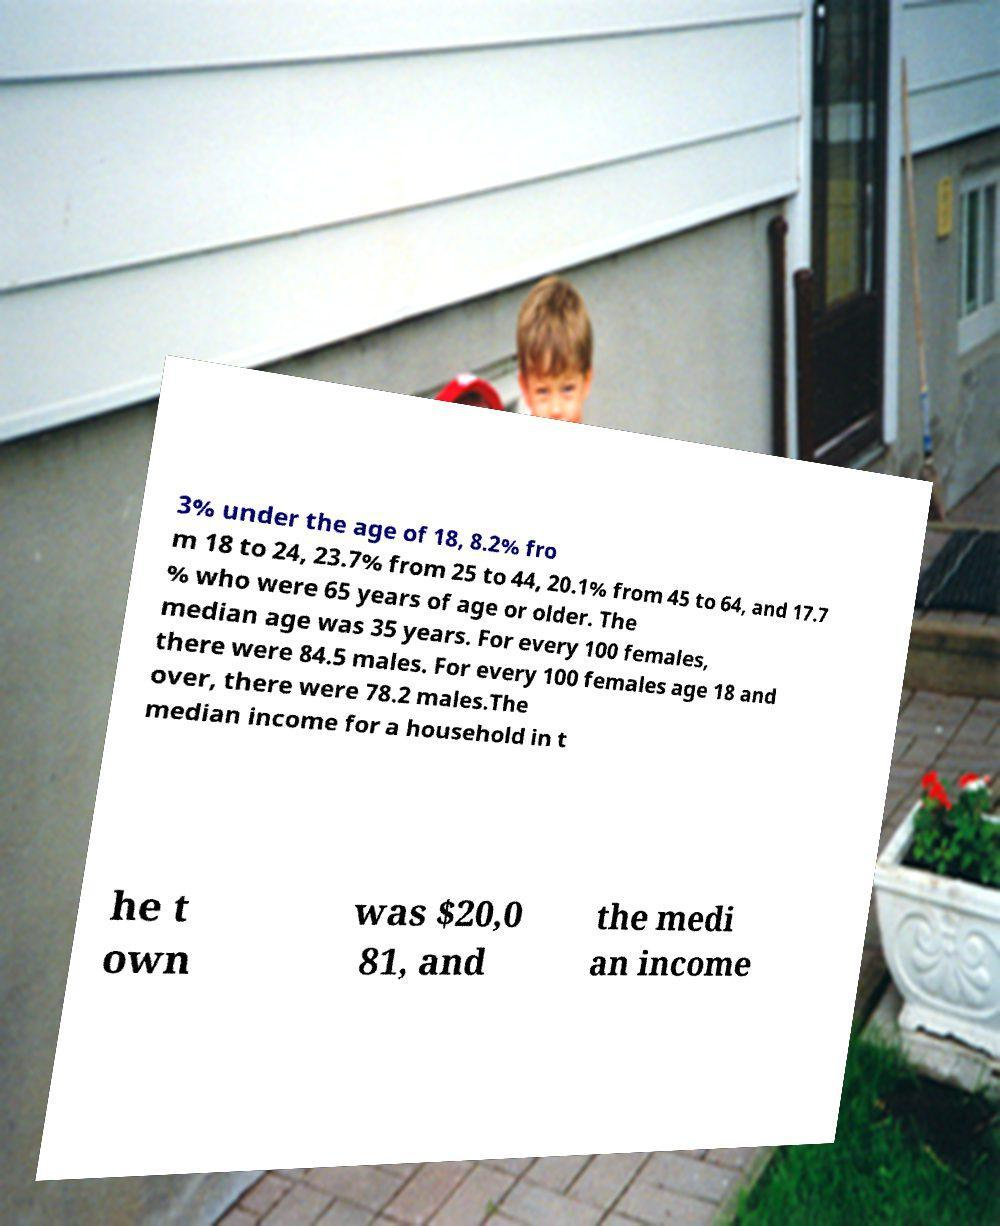Can you accurately transcribe the text from the provided image for me? 3% under the age of 18, 8.2% fro m 18 to 24, 23.7% from 25 to 44, 20.1% from 45 to 64, and 17.7 % who were 65 years of age or older. The median age was 35 years. For every 100 females, there were 84.5 males. For every 100 females age 18 and over, there were 78.2 males.The median income for a household in t he t own was $20,0 81, and the medi an income 